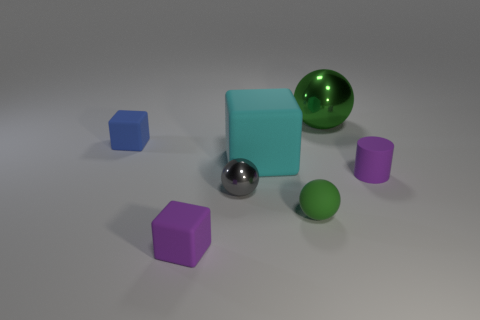Does the gray object have the same material as the green sphere that is behind the tiny purple cylinder?
Keep it short and to the point. Yes. Are the tiny purple cube and the small gray thing made of the same material?
Provide a short and direct response. No. Is there a purple matte thing behind the metal object in front of the large green sphere?
Your answer should be compact. Yes. What number of matte blocks are both behind the green rubber object and on the left side of the small gray sphere?
Your response must be concise. 1. What is the shape of the green object that is behind the gray metallic ball?
Offer a very short reply. Sphere. How many purple rubber things are the same size as the cyan thing?
Make the answer very short. 0. There is a rubber cube that is in front of the purple rubber cylinder; is its color the same as the cylinder?
Give a very brief answer. Yes. The small object that is behind the small shiny object and in front of the blue thing is made of what material?
Your answer should be very brief. Rubber. Are there more blue rubber blocks than objects?
Provide a short and direct response. No. There is a rubber block that is in front of the small purple thing that is behind the metal ball in front of the tiny blue matte cube; what color is it?
Give a very brief answer. Purple. 